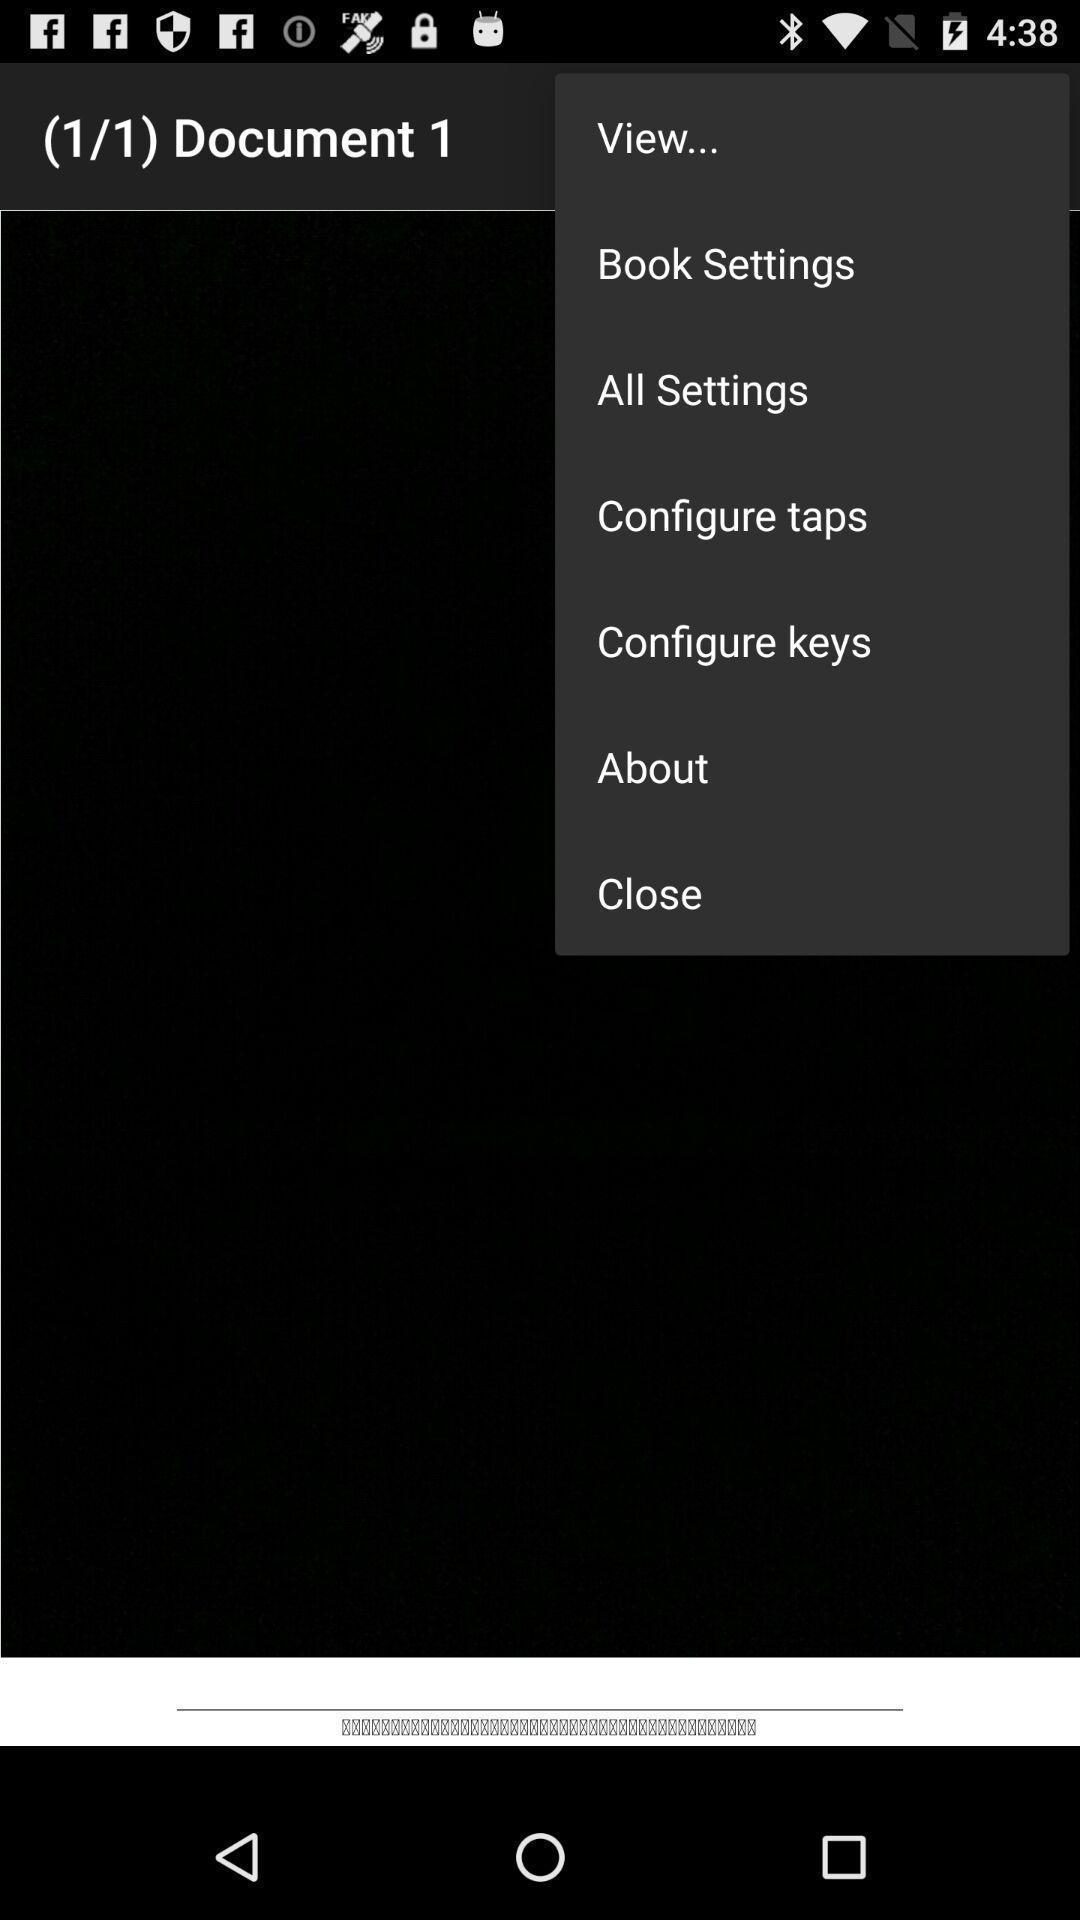Give me a narrative description of this picture. Pop up alert message with option. 